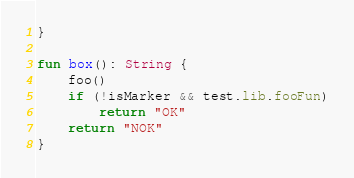<code> <loc_0><loc_0><loc_500><loc_500><_Kotlin_>}

fun box(): String {
    foo()
    if (!isMarker && test.lib.fooFun)
        return "OK"
    return "NOK"
}</code> 